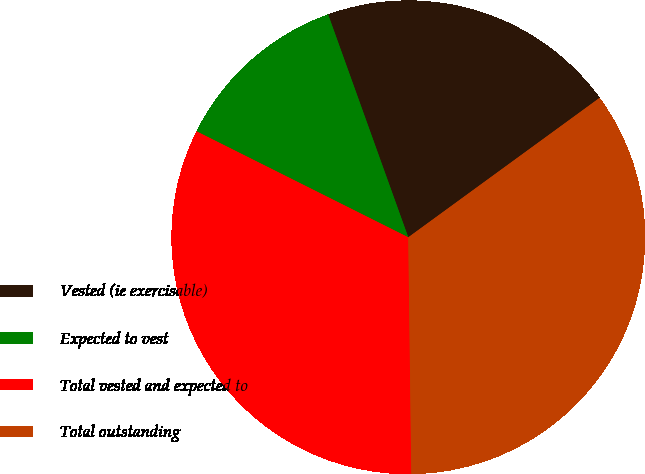<chart> <loc_0><loc_0><loc_500><loc_500><pie_chart><fcel>Vested (ie exercisable)<fcel>Expected to vest<fcel>Total vested and expected to<fcel>Total outstanding<nl><fcel>20.47%<fcel>12.12%<fcel>32.59%<fcel>34.82%<nl></chart> 